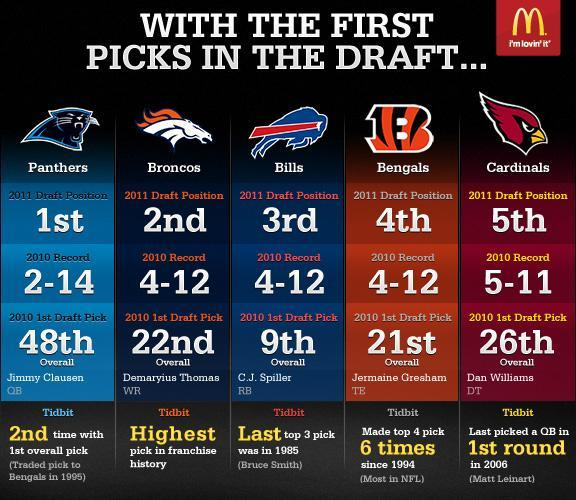How many teams had 4-12 record in 2010?
Answer the question with a short phrase. 3 